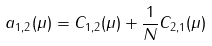Convert formula to latex. <formula><loc_0><loc_0><loc_500><loc_500>a _ { 1 , 2 } ( \mu ) = C _ { 1 , 2 } ( \mu ) + \frac { 1 } { N } C _ { 2 , 1 } ( \mu )</formula> 